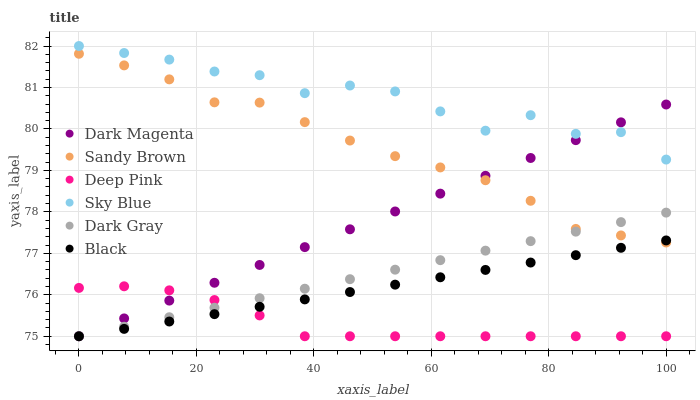Does Deep Pink have the minimum area under the curve?
Answer yes or no. Yes. Does Sky Blue have the maximum area under the curve?
Answer yes or no. Yes. Does Dark Magenta have the minimum area under the curve?
Answer yes or no. No. Does Dark Magenta have the maximum area under the curve?
Answer yes or no. No. Is Dark Gray the smoothest?
Answer yes or no. Yes. Is Sky Blue the roughest?
Answer yes or no. Yes. Is Dark Magenta the smoothest?
Answer yes or no. No. Is Dark Magenta the roughest?
Answer yes or no. No. Does Deep Pink have the lowest value?
Answer yes or no. Yes. Does Sky Blue have the lowest value?
Answer yes or no. No. Does Sky Blue have the highest value?
Answer yes or no. Yes. Does Dark Magenta have the highest value?
Answer yes or no. No. Is Sandy Brown less than Sky Blue?
Answer yes or no. Yes. Is Sky Blue greater than Sandy Brown?
Answer yes or no. Yes. Does Dark Gray intersect Sandy Brown?
Answer yes or no. Yes. Is Dark Gray less than Sandy Brown?
Answer yes or no. No. Is Dark Gray greater than Sandy Brown?
Answer yes or no. No. Does Sandy Brown intersect Sky Blue?
Answer yes or no. No. 